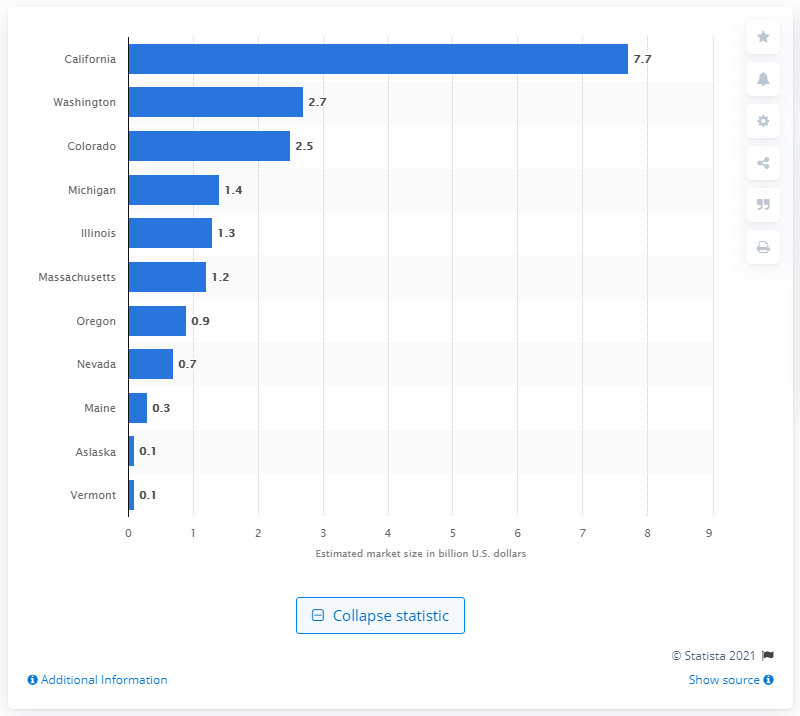List a handful of essential elements in this visual. The projected value of the cannabis market in California by 2022 is estimated to be approximately 7.7 billion dollars. 